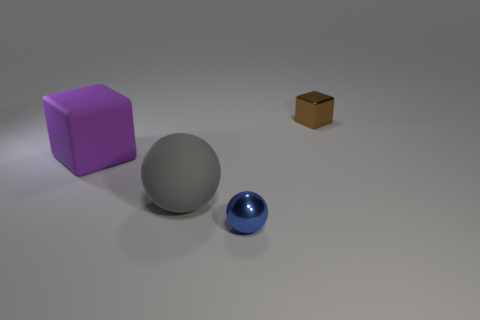Add 4 blue balls. How many objects exist? 8 Subtract all purple blocks. How many blocks are left? 1 Subtract 2 blocks. How many blocks are left? 0 Add 2 large gray matte balls. How many large gray matte balls are left? 3 Add 1 balls. How many balls exist? 3 Subtract 0 green spheres. How many objects are left? 4 Subtract all blue balls. Subtract all purple cubes. How many balls are left? 1 Subtract all metallic blocks. Subtract all brown objects. How many objects are left? 2 